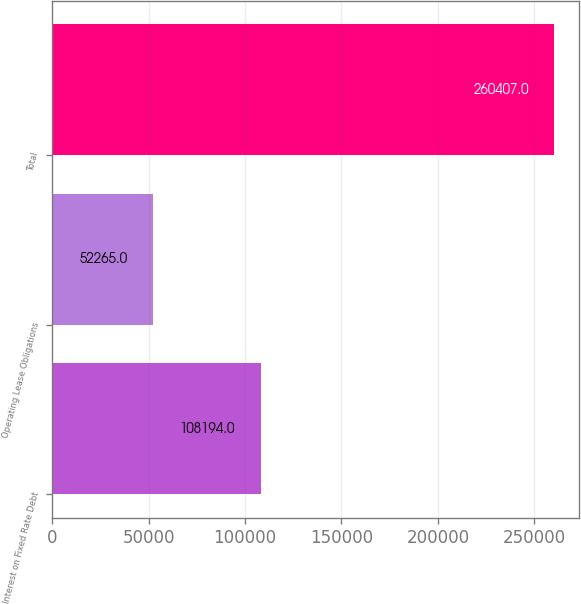Convert chart to OTSL. <chart><loc_0><loc_0><loc_500><loc_500><bar_chart><fcel>Interest on Fixed Rate Debt<fcel>Operating Lease Obligations<fcel>Total<nl><fcel>108194<fcel>52265<fcel>260407<nl></chart> 